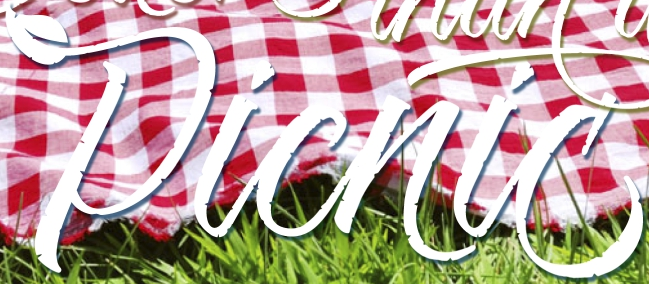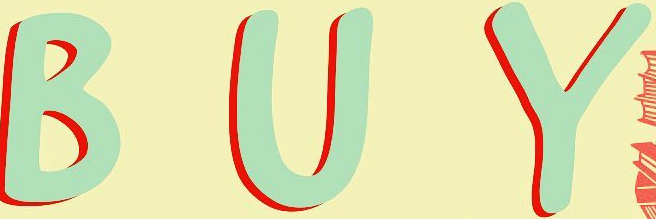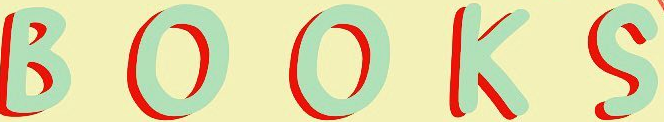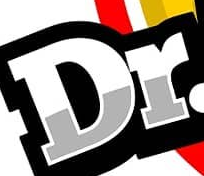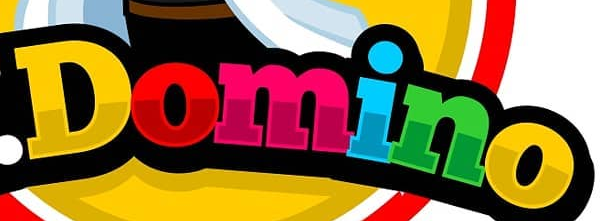Transcribe the words shown in these images in order, separated by a semicolon. Picnic; BUY; BOOKS; Dr; Domino 